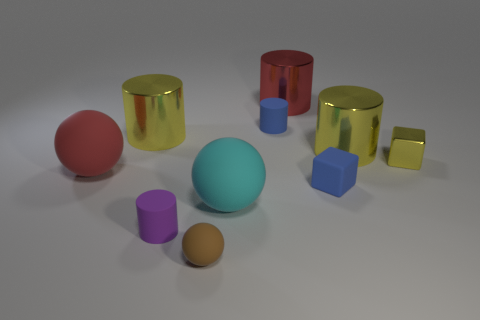Is there a small cylinder that has the same material as the tiny brown ball?
Your response must be concise. Yes. There is a large red thing that is behind the big thing that is right of the matte cube; what is it made of?
Give a very brief answer. Metal. What number of large objects are the same color as the tiny metal thing?
Your answer should be compact. 2. What is the size of the cyan object that is made of the same material as the purple object?
Your answer should be very brief. Large. The yellow metal thing that is left of the cyan rubber object has what shape?
Provide a short and direct response. Cylinder. There is another matte object that is the same shape as the small yellow thing; what is its size?
Give a very brief answer. Small. There is a tiny yellow thing that is on the right side of the large yellow cylinder that is on the right side of the large cyan sphere; how many cylinders are behind it?
Provide a short and direct response. 4. Are there the same number of cyan objects in front of the tiny matte sphere and big yellow rubber spheres?
Give a very brief answer. Yes. How many spheres are either tiny yellow metallic things or cyan things?
Your answer should be very brief. 1. Are there the same number of large cyan rubber spheres that are to the right of the tiny yellow object and matte balls that are to the left of the blue matte cylinder?
Provide a short and direct response. No. 